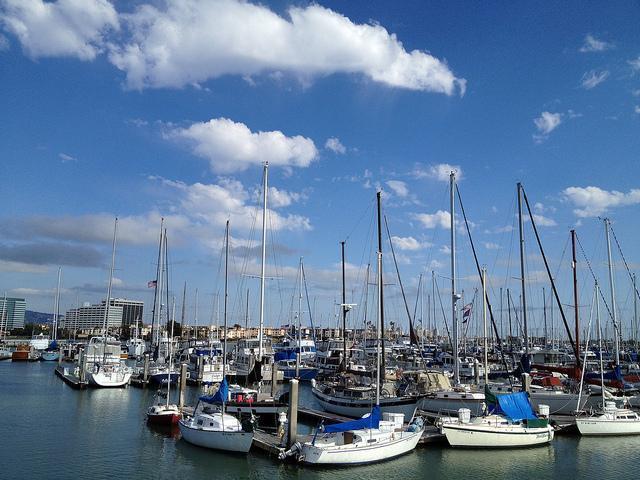How many boats are there?
Give a very brief answer. 8. 